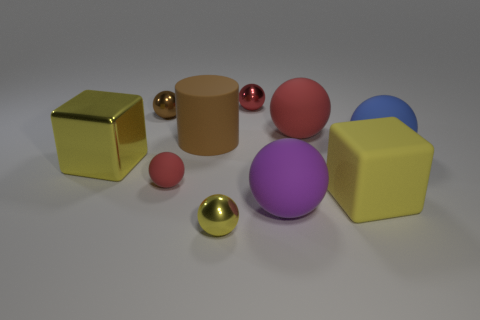Is the color of the rubber cube the same as the small matte thing?
Offer a terse response. No. What number of other objects are there of the same material as the large purple ball?
Provide a succinct answer. 5. There is a large rubber sphere that is in front of the yellow block left of the cube right of the small yellow shiny ball; what is its color?
Your answer should be compact. Purple. What is the material of the purple thing that is the same size as the brown rubber thing?
Your answer should be very brief. Rubber. What number of objects are tiny balls that are in front of the brown shiny sphere or small spheres?
Give a very brief answer. 4. Are any large yellow rubber blocks visible?
Ensure brevity in your answer.  Yes. There is a tiny red sphere that is behind the blue rubber thing; what is it made of?
Ensure brevity in your answer.  Metal. There is a small sphere that is the same color as the shiny block; what is it made of?
Your response must be concise. Metal. What number of tiny things are either shiny balls or yellow metallic cubes?
Provide a succinct answer. 3. What is the color of the large cylinder?
Provide a succinct answer. Brown. 